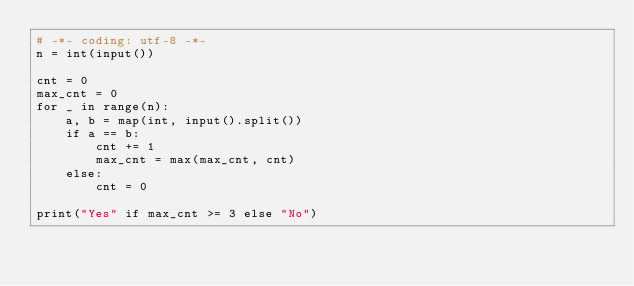<code> <loc_0><loc_0><loc_500><loc_500><_Python_># -*- coding: utf-8 -*-
n = int(input())

cnt = 0
max_cnt = 0
for _ in range(n):
    a, b = map(int, input().split())
    if a == b:
        cnt += 1
        max_cnt = max(max_cnt, cnt)
    else:
        cnt = 0

print("Yes" if max_cnt >= 3 else "No")
</code> 